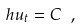<formula> <loc_0><loc_0><loc_500><loc_500>h u _ { t } = C \ ,</formula> 